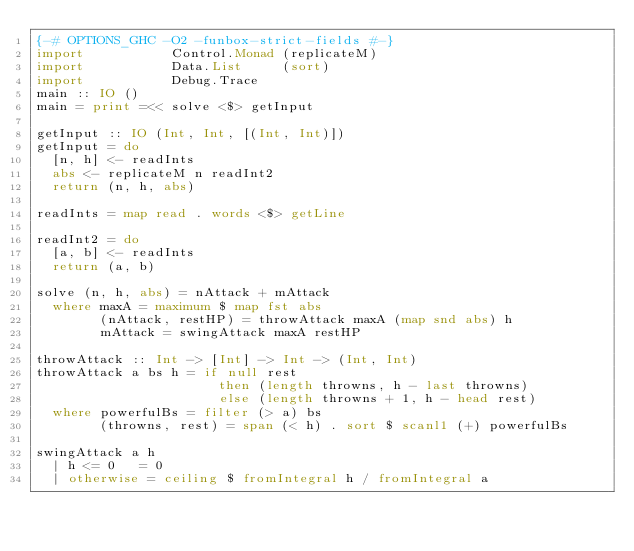<code> <loc_0><loc_0><loc_500><loc_500><_Haskell_>{-# OPTIONS_GHC -O2 -funbox-strict-fields #-}
import           Control.Monad (replicateM)
import           Data.List     (sort)
import           Debug.Trace
main :: IO ()
main = print =<< solve <$> getInput

getInput :: IO (Int, Int, [(Int, Int)])
getInput = do
  [n, h] <- readInts
  abs <- replicateM n readInt2
  return (n, h, abs)

readInts = map read . words <$> getLine

readInt2 = do
  [a, b] <- readInts
  return (a, b)

solve (n, h, abs) = nAttack + mAttack
  where maxA = maximum $ map fst abs
        (nAttack, restHP) = throwAttack maxA (map snd abs) h
        mAttack = swingAttack maxA restHP

throwAttack :: Int -> [Int] -> Int -> (Int, Int)
throwAttack a bs h = if null rest
                       then (length throwns, h - last throwns)
                       else (length throwns + 1, h - head rest)
  where powerfulBs = filter (> a) bs
        (throwns, rest) = span (< h) . sort $ scanl1 (+) powerfulBs

swingAttack a h
  | h <= 0   = 0
  | otherwise = ceiling $ fromIntegral h / fromIntegral a
</code> 